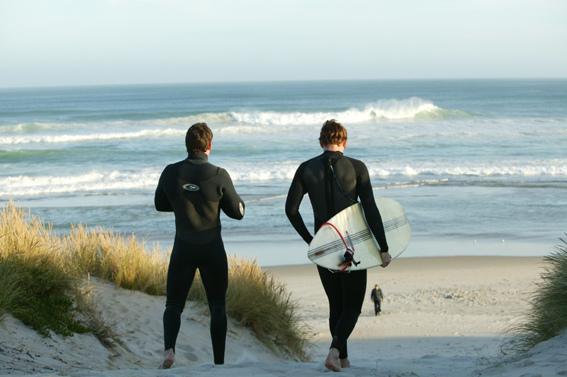How many men in this scene?
Give a very brief answer. 2. Is the water cold or hot?
Keep it brief. Cold. Is the man on the left wearing a wetsuit?
Be succinct. Yes. 